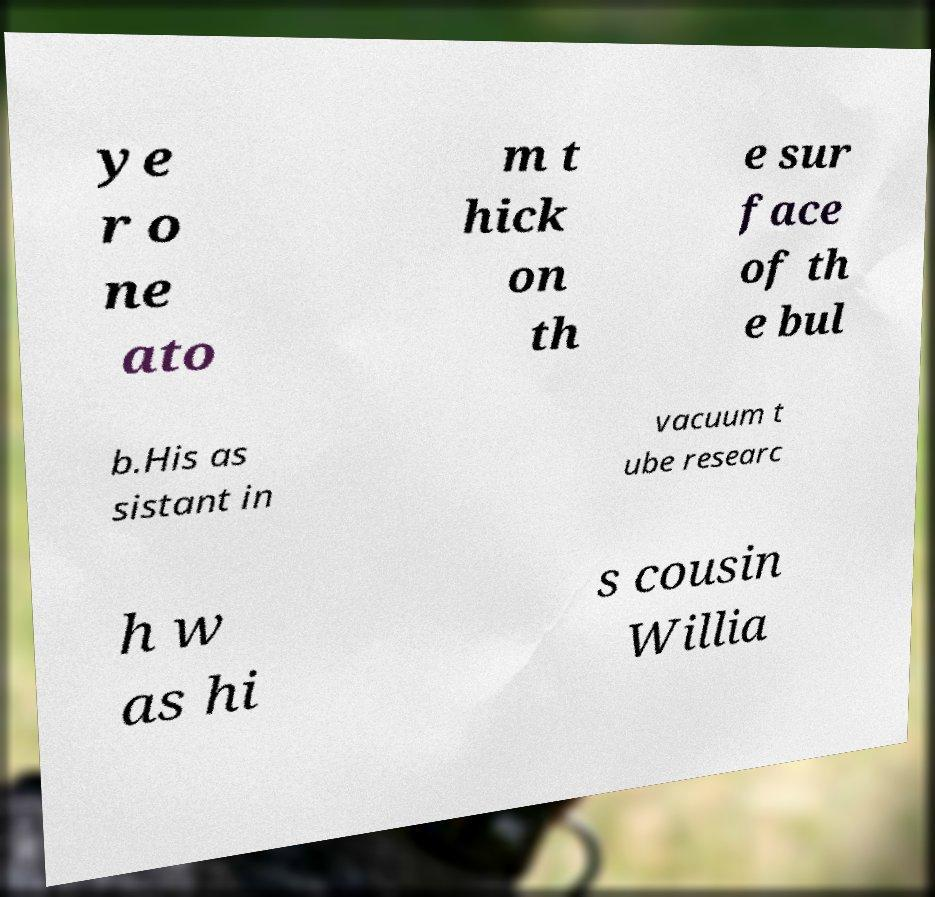There's text embedded in this image that I need extracted. Can you transcribe it verbatim? ye r o ne ato m t hick on th e sur face of th e bul b.His as sistant in vacuum t ube researc h w as hi s cousin Willia 